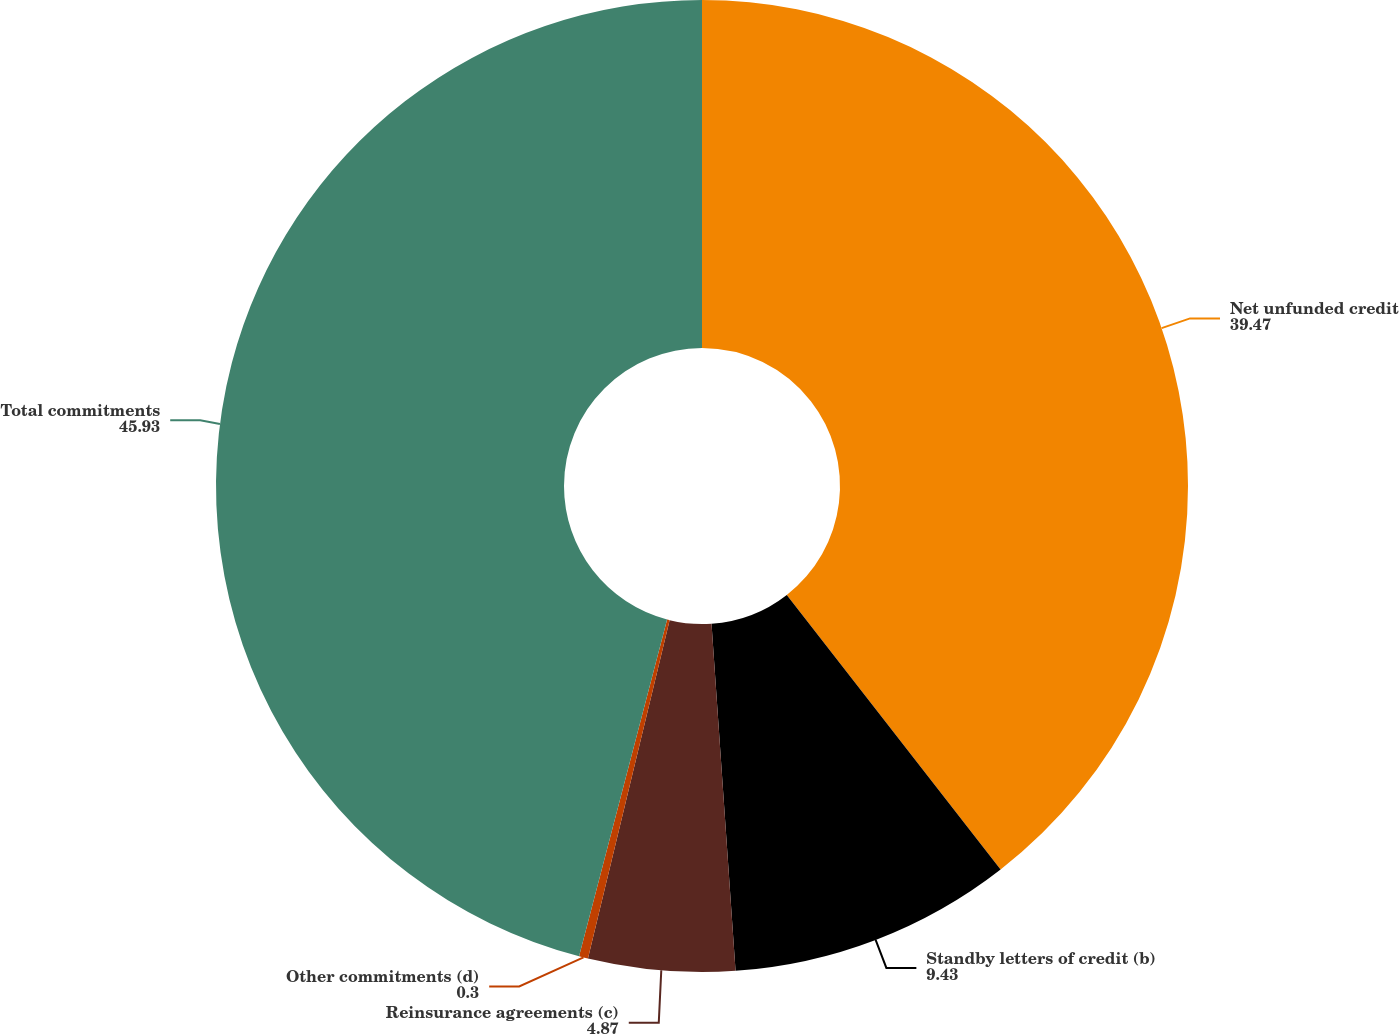Convert chart. <chart><loc_0><loc_0><loc_500><loc_500><pie_chart><fcel>Net unfunded credit<fcel>Standby letters of credit (b)<fcel>Reinsurance agreements (c)<fcel>Other commitments (d)<fcel>Total commitments<nl><fcel>39.47%<fcel>9.43%<fcel>4.87%<fcel>0.3%<fcel>45.93%<nl></chart> 